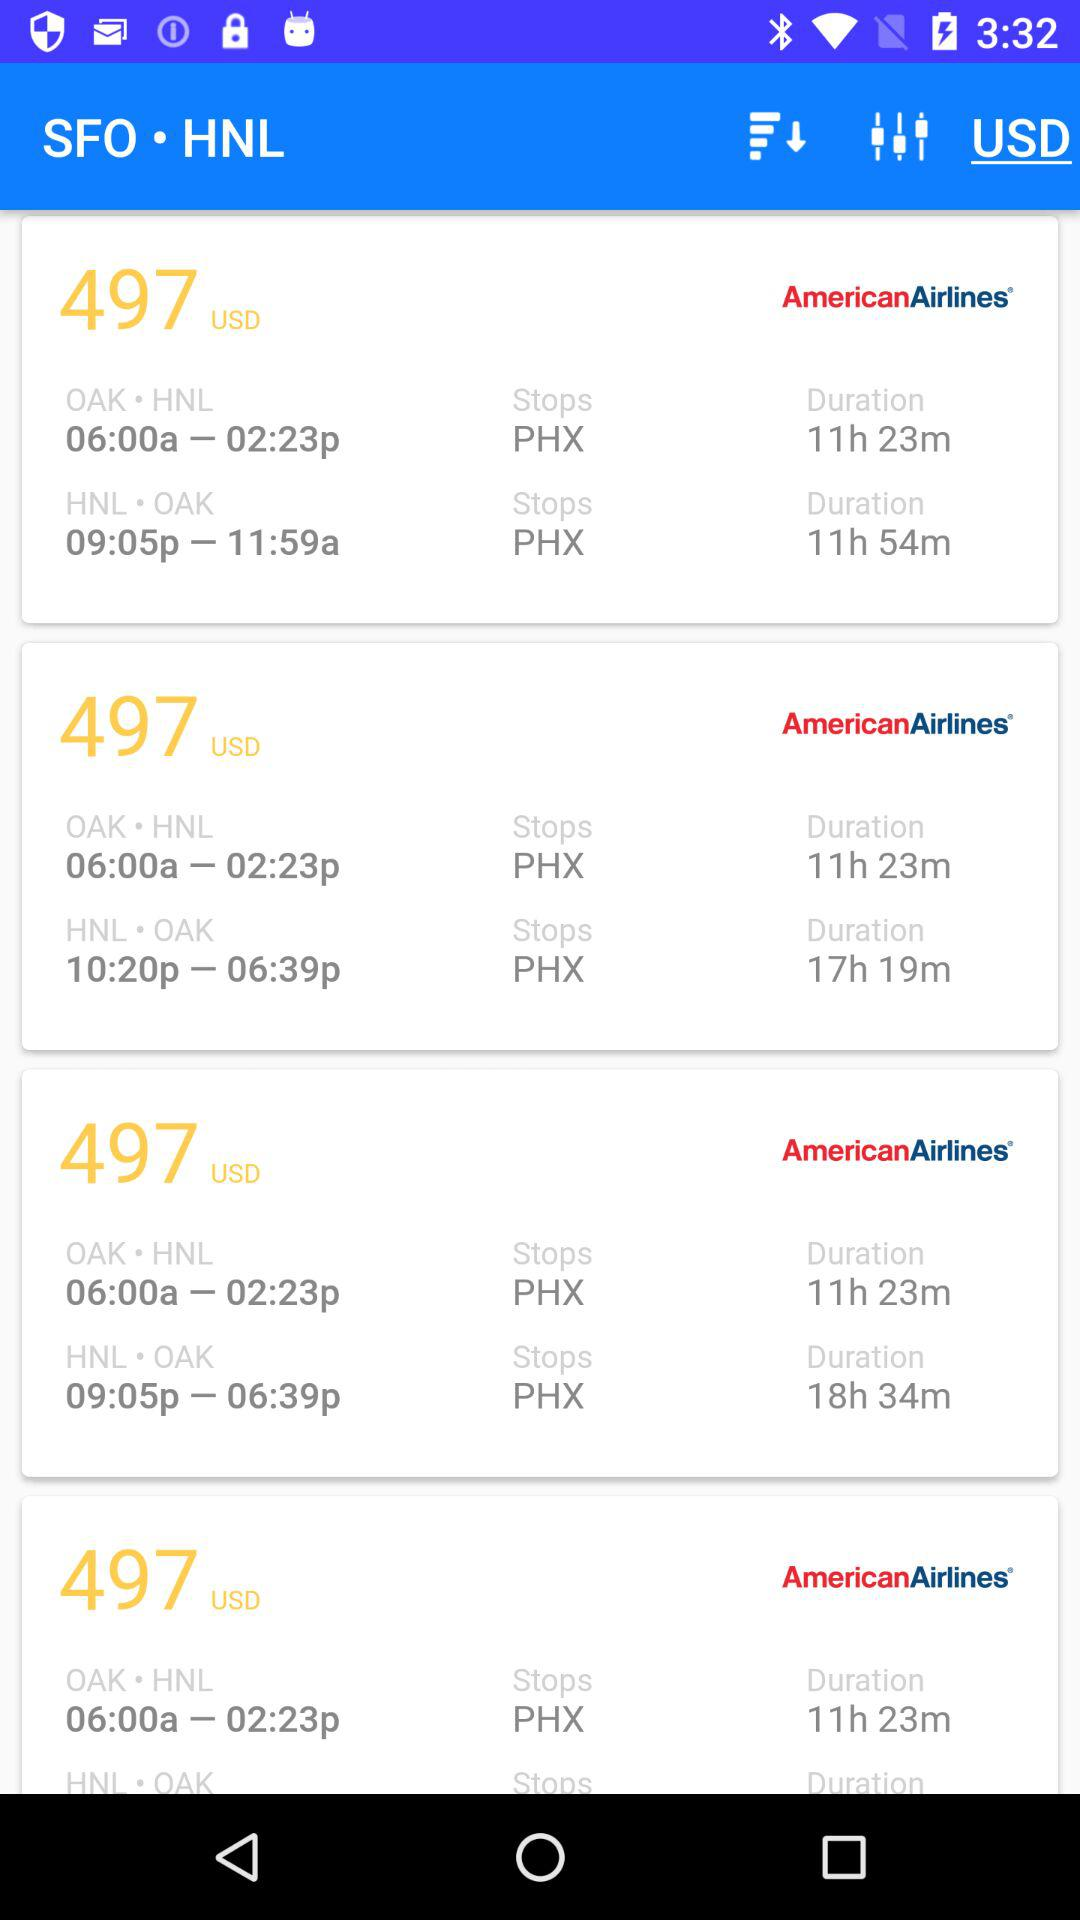Shortest duration Flight time?
When the provided information is insufficient, respond with <no answer>. <no answer> 